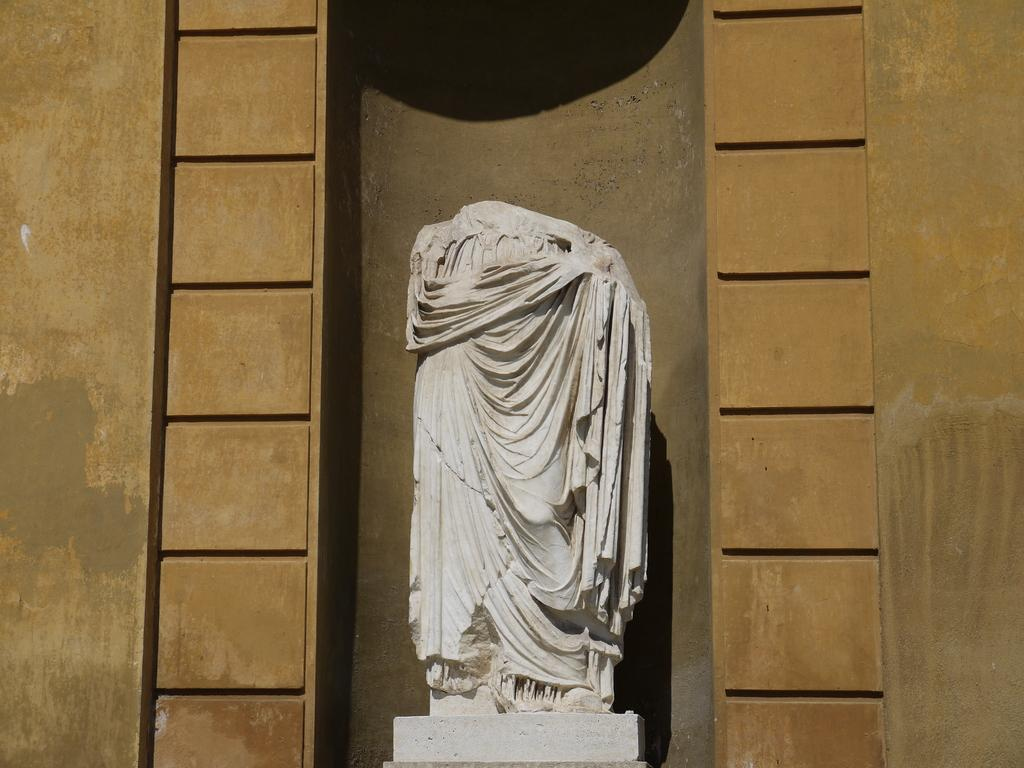What is placed on the statue in the image? There is a cloth on a statue in the image. What type of structure can be seen in the background of the image? There is a wall visible in the image. What type of expert advice is being given in the image? There is no expert or advice present in the image; it features a statue with a cloth on it and a wall in the background. What type of haircut is being given to the statue in the image? There is no haircut being given to the statue in the image; it features a statue with a cloth on it and a wall in the background. 